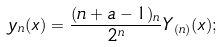Convert formula to latex. <formula><loc_0><loc_0><loc_500><loc_500>y _ { n } ( x ) = \frac { ( n + a - 1 ) _ { n } } { 2 ^ { n } } Y _ { ( n ) } ( x ) ;</formula> 